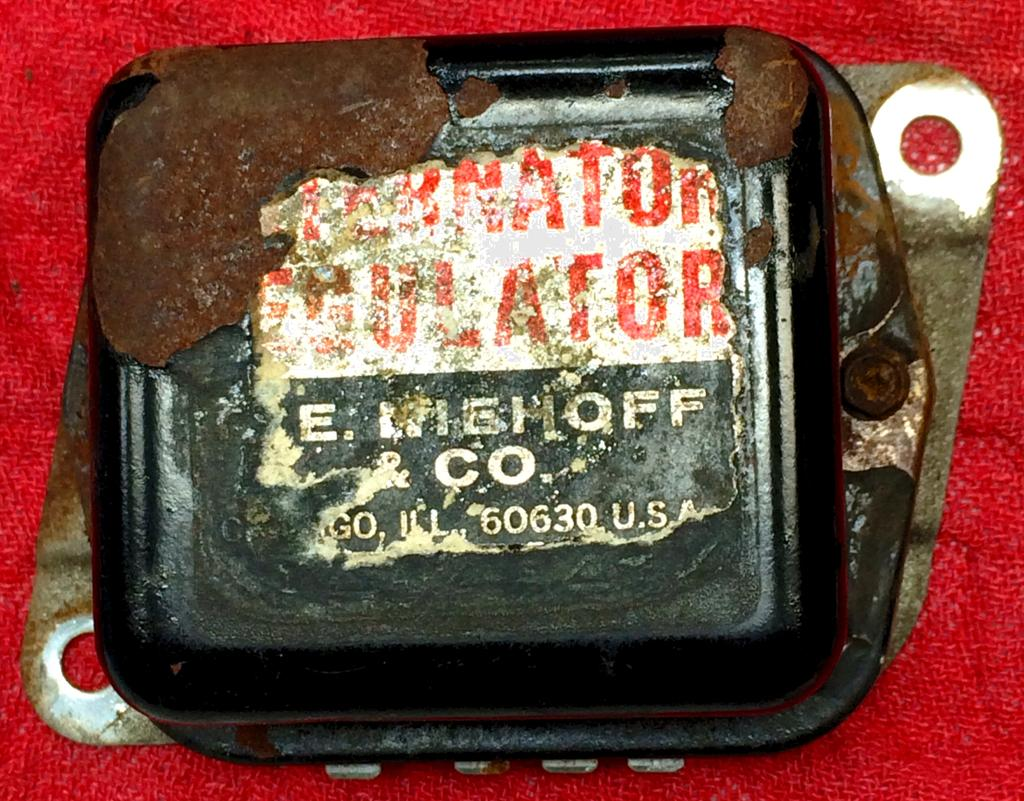What type of object is the metal regulator in the image? The metal regulator is a type of object in the image. What is the color of the cloth in the image? The cloth in the image is red in color. What time of day is it in the image, and is there a bomb present? The time of day cannot be determined from the image, and there is no bomb present in the image. What type of peace symbol can be seen in the image? There is no peace symbol present in the image. 